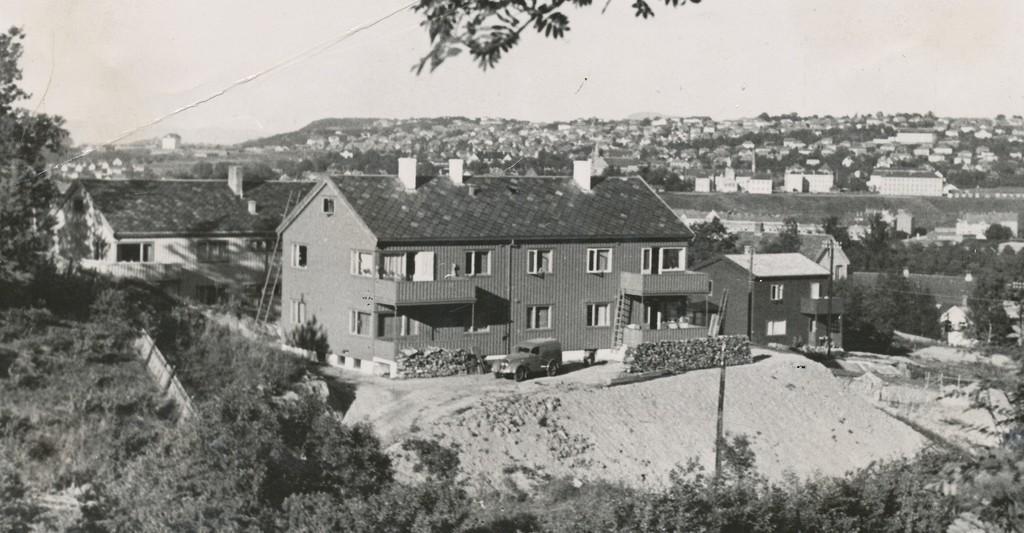Please provide a concise description of this image. In this image I can see number of buildings, number of trees and in the center I can see a vehicle. I can also see few ladders near to the front building and I can see this image is black and white in colour. 